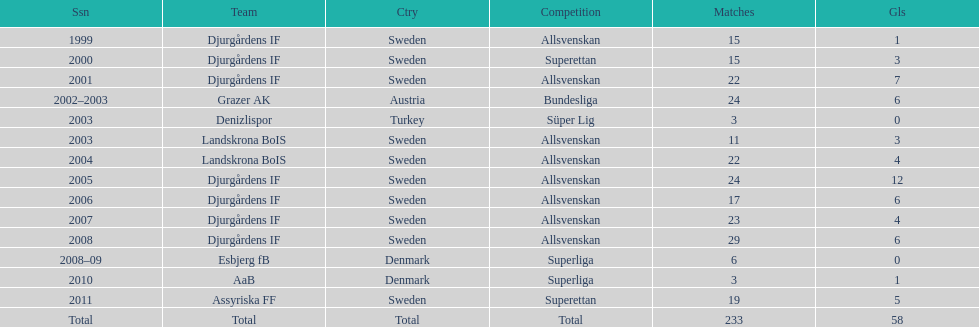What is the total number of matches? 233. 